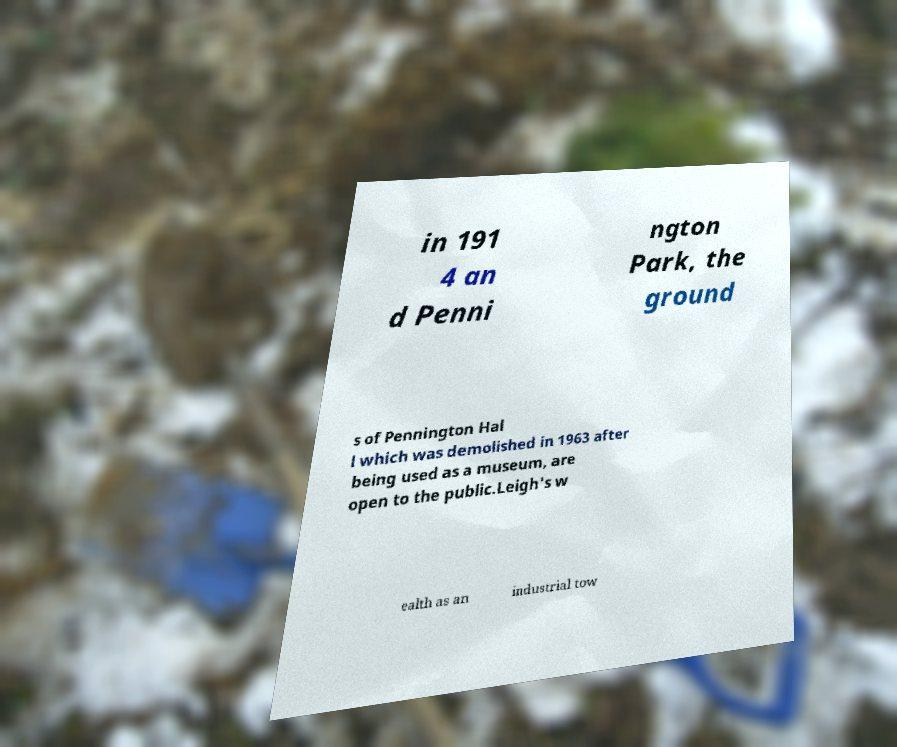Please read and relay the text visible in this image. What does it say? in 191 4 an d Penni ngton Park, the ground s of Pennington Hal l which was demolished in 1963 after being used as a museum, are open to the public.Leigh's w ealth as an industrial tow 